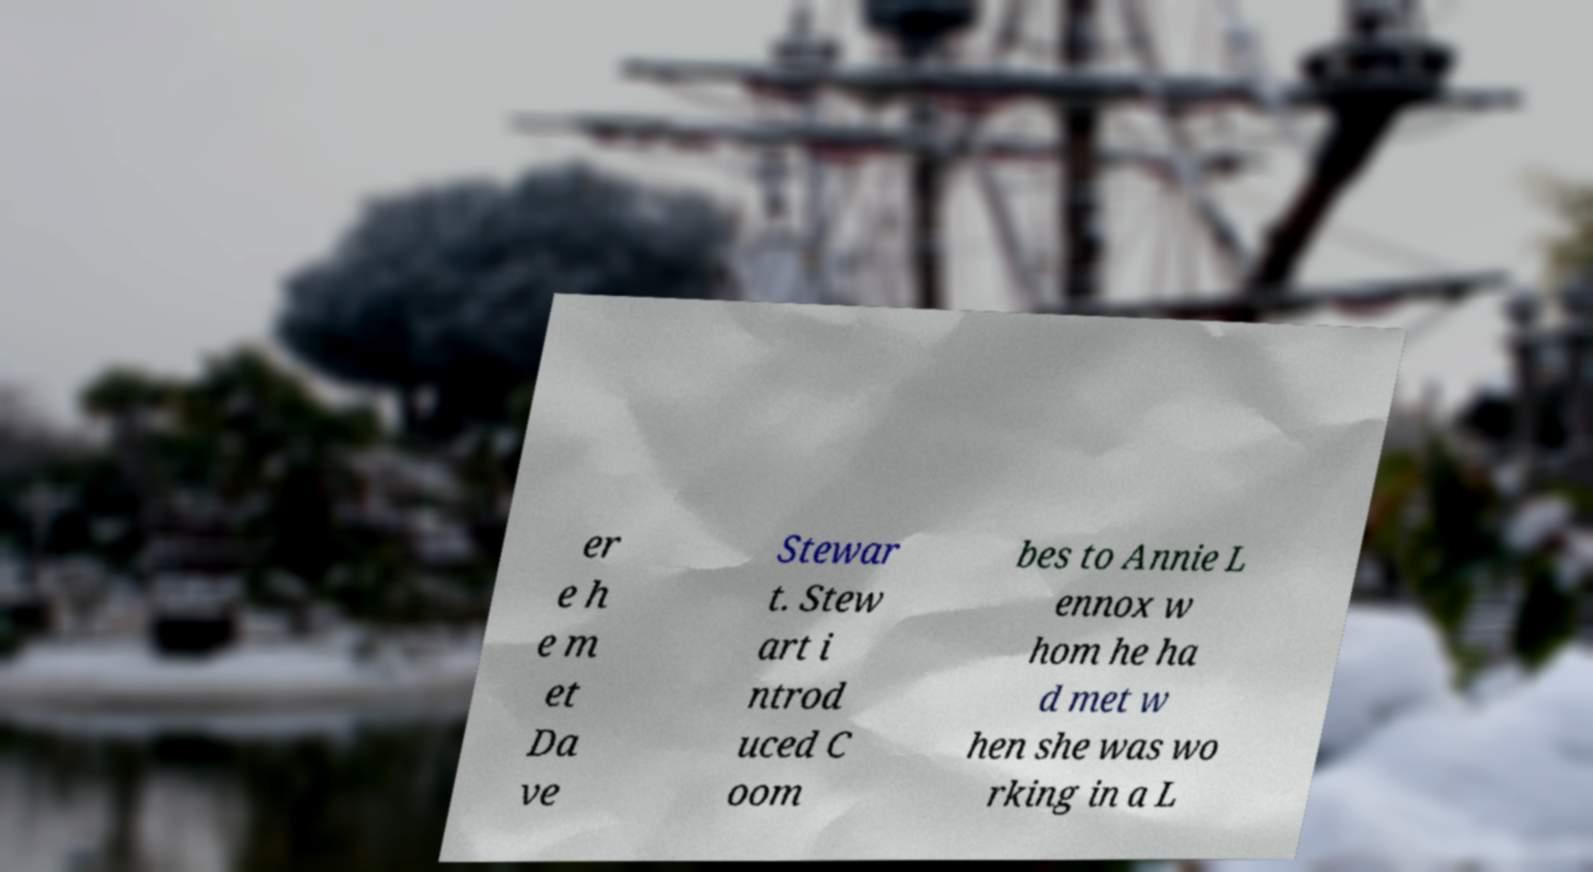What messages or text are displayed in this image? I need them in a readable, typed format. er e h e m et Da ve Stewar t. Stew art i ntrod uced C oom bes to Annie L ennox w hom he ha d met w hen she was wo rking in a L 